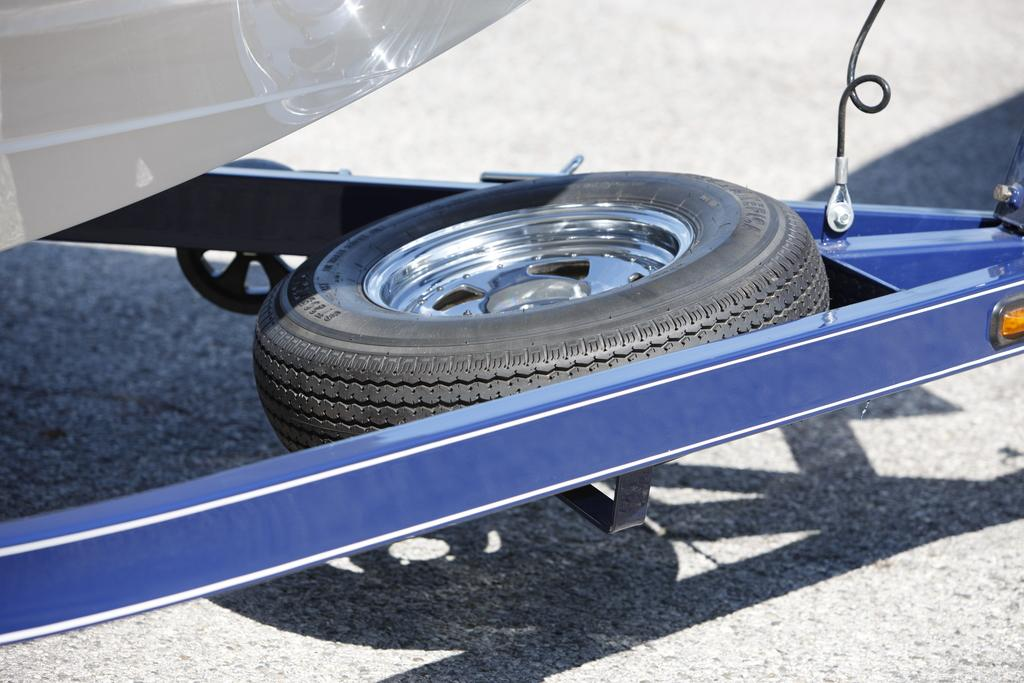What object is present in the image? There is a wheel in the image. What color is the wheel? The wheel is black in color. Where is the wheel located? The wheel is on the road. Can you see a cow standing next to the wheel in the image? No, there is no cow present in the image. 